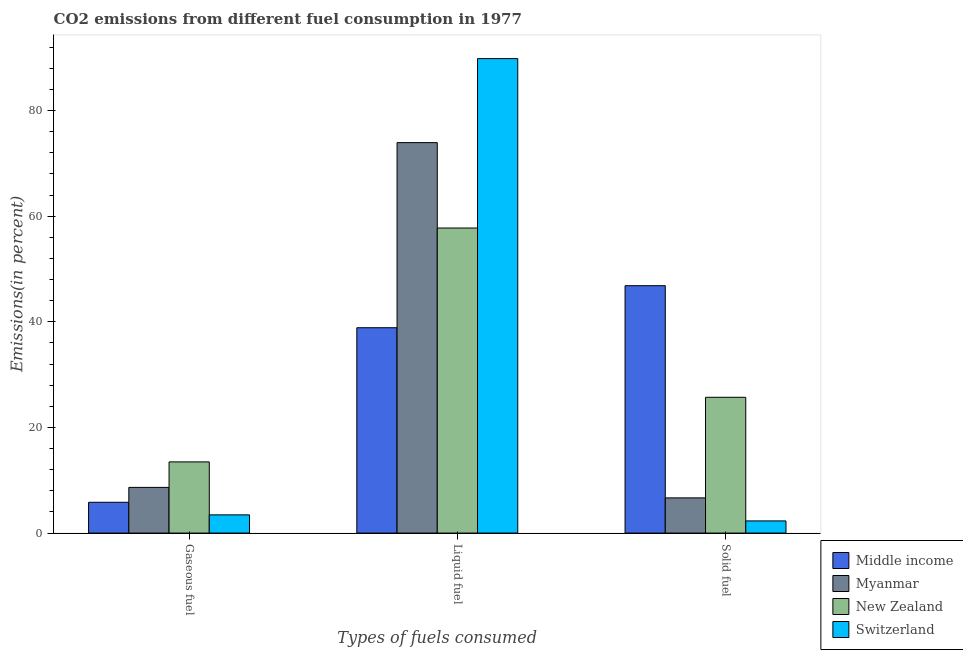Are the number of bars on each tick of the X-axis equal?
Give a very brief answer. Yes. How many bars are there on the 2nd tick from the left?
Your answer should be very brief. 4. How many bars are there on the 2nd tick from the right?
Ensure brevity in your answer.  4. What is the label of the 2nd group of bars from the left?
Give a very brief answer. Liquid fuel. What is the percentage of liquid fuel emission in New Zealand?
Your response must be concise. 57.75. Across all countries, what is the maximum percentage of solid fuel emission?
Keep it short and to the point. 46.83. Across all countries, what is the minimum percentage of solid fuel emission?
Offer a terse response. 2.3. In which country was the percentage of gaseous fuel emission maximum?
Provide a short and direct response. New Zealand. In which country was the percentage of gaseous fuel emission minimum?
Your answer should be very brief. Switzerland. What is the total percentage of solid fuel emission in the graph?
Provide a short and direct response. 81.5. What is the difference between the percentage of gaseous fuel emission in Myanmar and that in Switzerland?
Provide a succinct answer. 5.2. What is the difference between the percentage of liquid fuel emission in Switzerland and the percentage of solid fuel emission in Middle income?
Give a very brief answer. 42.99. What is the average percentage of gaseous fuel emission per country?
Your response must be concise. 7.85. What is the difference between the percentage of solid fuel emission and percentage of liquid fuel emission in New Zealand?
Your answer should be compact. -32.04. In how many countries, is the percentage of solid fuel emission greater than 60 %?
Provide a succinct answer. 0. What is the ratio of the percentage of gaseous fuel emission in New Zealand to that in Switzerland?
Your answer should be very brief. 3.91. Is the percentage of solid fuel emission in Myanmar less than that in Middle income?
Provide a short and direct response. Yes. What is the difference between the highest and the second highest percentage of gaseous fuel emission?
Offer a terse response. 4.83. What is the difference between the highest and the lowest percentage of solid fuel emission?
Provide a short and direct response. 44.53. In how many countries, is the percentage of liquid fuel emission greater than the average percentage of liquid fuel emission taken over all countries?
Your answer should be compact. 2. What does the 1st bar from the left in Solid fuel represents?
Provide a succinct answer. Middle income. What does the 1st bar from the right in Gaseous fuel represents?
Give a very brief answer. Switzerland. How many bars are there?
Provide a short and direct response. 12. Are all the bars in the graph horizontal?
Make the answer very short. No. How many countries are there in the graph?
Your answer should be compact. 4. What is the difference between two consecutive major ticks on the Y-axis?
Offer a very short reply. 20. Where does the legend appear in the graph?
Keep it short and to the point. Bottom right. What is the title of the graph?
Your response must be concise. CO2 emissions from different fuel consumption in 1977. Does "Sao Tome and Principe" appear as one of the legend labels in the graph?
Make the answer very short. No. What is the label or title of the X-axis?
Make the answer very short. Types of fuels consumed. What is the label or title of the Y-axis?
Your answer should be compact. Emissions(in percent). What is the Emissions(in percent) of Middle income in Gaseous fuel?
Ensure brevity in your answer.  5.83. What is the Emissions(in percent) in Myanmar in Gaseous fuel?
Provide a succinct answer. 8.65. What is the Emissions(in percent) in New Zealand in Gaseous fuel?
Provide a succinct answer. 13.48. What is the Emissions(in percent) of Switzerland in Gaseous fuel?
Your answer should be compact. 3.45. What is the Emissions(in percent) in Middle income in Liquid fuel?
Make the answer very short. 38.88. What is the Emissions(in percent) of Myanmar in Liquid fuel?
Your answer should be very brief. 73.92. What is the Emissions(in percent) in New Zealand in Liquid fuel?
Provide a short and direct response. 57.75. What is the Emissions(in percent) in Switzerland in Liquid fuel?
Give a very brief answer. 89.83. What is the Emissions(in percent) of Middle income in Solid fuel?
Provide a short and direct response. 46.83. What is the Emissions(in percent) in Myanmar in Solid fuel?
Give a very brief answer. 6.66. What is the Emissions(in percent) in New Zealand in Solid fuel?
Provide a succinct answer. 25.7. What is the Emissions(in percent) of Switzerland in Solid fuel?
Offer a terse response. 2.3. Across all Types of fuels consumed, what is the maximum Emissions(in percent) in Middle income?
Your answer should be compact. 46.83. Across all Types of fuels consumed, what is the maximum Emissions(in percent) in Myanmar?
Offer a very short reply. 73.92. Across all Types of fuels consumed, what is the maximum Emissions(in percent) in New Zealand?
Provide a succinct answer. 57.75. Across all Types of fuels consumed, what is the maximum Emissions(in percent) of Switzerland?
Your answer should be compact. 89.83. Across all Types of fuels consumed, what is the minimum Emissions(in percent) of Middle income?
Give a very brief answer. 5.83. Across all Types of fuels consumed, what is the minimum Emissions(in percent) in Myanmar?
Your response must be concise. 6.66. Across all Types of fuels consumed, what is the minimum Emissions(in percent) in New Zealand?
Your answer should be compact. 13.48. Across all Types of fuels consumed, what is the minimum Emissions(in percent) in Switzerland?
Keep it short and to the point. 2.3. What is the total Emissions(in percent) of Middle income in the graph?
Provide a succinct answer. 91.54. What is the total Emissions(in percent) in Myanmar in the graph?
Your answer should be very brief. 89.23. What is the total Emissions(in percent) of New Zealand in the graph?
Give a very brief answer. 96.93. What is the total Emissions(in percent) in Switzerland in the graph?
Your response must be concise. 95.57. What is the difference between the Emissions(in percent) of Middle income in Gaseous fuel and that in Liquid fuel?
Offer a very short reply. -33.05. What is the difference between the Emissions(in percent) of Myanmar in Gaseous fuel and that in Liquid fuel?
Your answer should be compact. -65.27. What is the difference between the Emissions(in percent) in New Zealand in Gaseous fuel and that in Liquid fuel?
Offer a terse response. -44.27. What is the difference between the Emissions(in percent) of Switzerland in Gaseous fuel and that in Liquid fuel?
Give a very brief answer. -86.38. What is the difference between the Emissions(in percent) of Middle income in Gaseous fuel and that in Solid fuel?
Offer a terse response. -41. What is the difference between the Emissions(in percent) in Myanmar in Gaseous fuel and that in Solid fuel?
Provide a short and direct response. 1.98. What is the difference between the Emissions(in percent) in New Zealand in Gaseous fuel and that in Solid fuel?
Make the answer very short. -12.23. What is the difference between the Emissions(in percent) in Switzerland in Gaseous fuel and that in Solid fuel?
Offer a terse response. 1.14. What is the difference between the Emissions(in percent) of Middle income in Liquid fuel and that in Solid fuel?
Offer a very short reply. -7.96. What is the difference between the Emissions(in percent) of Myanmar in Liquid fuel and that in Solid fuel?
Give a very brief answer. 67.26. What is the difference between the Emissions(in percent) of New Zealand in Liquid fuel and that in Solid fuel?
Make the answer very short. 32.04. What is the difference between the Emissions(in percent) in Switzerland in Liquid fuel and that in Solid fuel?
Your answer should be very brief. 87.52. What is the difference between the Emissions(in percent) of Middle income in Gaseous fuel and the Emissions(in percent) of Myanmar in Liquid fuel?
Your answer should be compact. -68.09. What is the difference between the Emissions(in percent) of Middle income in Gaseous fuel and the Emissions(in percent) of New Zealand in Liquid fuel?
Provide a short and direct response. -51.92. What is the difference between the Emissions(in percent) of Middle income in Gaseous fuel and the Emissions(in percent) of Switzerland in Liquid fuel?
Your answer should be compact. -84. What is the difference between the Emissions(in percent) in Myanmar in Gaseous fuel and the Emissions(in percent) in New Zealand in Liquid fuel?
Your answer should be very brief. -49.1. What is the difference between the Emissions(in percent) in Myanmar in Gaseous fuel and the Emissions(in percent) in Switzerland in Liquid fuel?
Your answer should be very brief. -81.18. What is the difference between the Emissions(in percent) of New Zealand in Gaseous fuel and the Emissions(in percent) of Switzerland in Liquid fuel?
Offer a terse response. -76.35. What is the difference between the Emissions(in percent) in Middle income in Gaseous fuel and the Emissions(in percent) in Myanmar in Solid fuel?
Provide a succinct answer. -0.83. What is the difference between the Emissions(in percent) in Middle income in Gaseous fuel and the Emissions(in percent) in New Zealand in Solid fuel?
Keep it short and to the point. -19.87. What is the difference between the Emissions(in percent) in Middle income in Gaseous fuel and the Emissions(in percent) in Switzerland in Solid fuel?
Your answer should be compact. 3.53. What is the difference between the Emissions(in percent) in Myanmar in Gaseous fuel and the Emissions(in percent) in New Zealand in Solid fuel?
Make the answer very short. -17.06. What is the difference between the Emissions(in percent) in Myanmar in Gaseous fuel and the Emissions(in percent) in Switzerland in Solid fuel?
Make the answer very short. 6.34. What is the difference between the Emissions(in percent) of New Zealand in Gaseous fuel and the Emissions(in percent) of Switzerland in Solid fuel?
Your answer should be compact. 11.17. What is the difference between the Emissions(in percent) of Middle income in Liquid fuel and the Emissions(in percent) of Myanmar in Solid fuel?
Keep it short and to the point. 32.21. What is the difference between the Emissions(in percent) in Middle income in Liquid fuel and the Emissions(in percent) in New Zealand in Solid fuel?
Provide a succinct answer. 13.17. What is the difference between the Emissions(in percent) in Middle income in Liquid fuel and the Emissions(in percent) in Switzerland in Solid fuel?
Keep it short and to the point. 36.57. What is the difference between the Emissions(in percent) of Myanmar in Liquid fuel and the Emissions(in percent) of New Zealand in Solid fuel?
Ensure brevity in your answer.  48.21. What is the difference between the Emissions(in percent) in Myanmar in Liquid fuel and the Emissions(in percent) in Switzerland in Solid fuel?
Give a very brief answer. 71.62. What is the difference between the Emissions(in percent) of New Zealand in Liquid fuel and the Emissions(in percent) of Switzerland in Solid fuel?
Provide a succinct answer. 55.45. What is the average Emissions(in percent) in Middle income per Types of fuels consumed?
Give a very brief answer. 30.51. What is the average Emissions(in percent) of Myanmar per Types of fuels consumed?
Offer a terse response. 29.74. What is the average Emissions(in percent) of New Zealand per Types of fuels consumed?
Provide a short and direct response. 32.31. What is the average Emissions(in percent) of Switzerland per Types of fuels consumed?
Make the answer very short. 31.86. What is the difference between the Emissions(in percent) of Middle income and Emissions(in percent) of Myanmar in Gaseous fuel?
Offer a terse response. -2.82. What is the difference between the Emissions(in percent) in Middle income and Emissions(in percent) in New Zealand in Gaseous fuel?
Your response must be concise. -7.65. What is the difference between the Emissions(in percent) of Middle income and Emissions(in percent) of Switzerland in Gaseous fuel?
Your answer should be very brief. 2.38. What is the difference between the Emissions(in percent) in Myanmar and Emissions(in percent) in New Zealand in Gaseous fuel?
Provide a succinct answer. -4.83. What is the difference between the Emissions(in percent) of Myanmar and Emissions(in percent) of Switzerland in Gaseous fuel?
Keep it short and to the point. 5.2. What is the difference between the Emissions(in percent) of New Zealand and Emissions(in percent) of Switzerland in Gaseous fuel?
Your answer should be very brief. 10.03. What is the difference between the Emissions(in percent) in Middle income and Emissions(in percent) in Myanmar in Liquid fuel?
Keep it short and to the point. -35.04. What is the difference between the Emissions(in percent) in Middle income and Emissions(in percent) in New Zealand in Liquid fuel?
Your answer should be compact. -18.87. What is the difference between the Emissions(in percent) of Middle income and Emissions(in percent) of Switzerland in Liquid fuel?
Provide a short and direct response. -50.95. What is the difference between the Emissions(in percent) of Myanmar and Emissions(in percent) of New Zealand in Liquid fuel?
Give a very brief answer. 16.17. What is the difference between the Emissions(in percent) of Myanmar and Emissions(in percent) of Switzerland in Liquid fuel?
Make the answer very short. -15.91. What is the difference between the Emissions(in percent) in New Zealand and Emissions(in percent) in Switzerland in Liquid fuel?
Provide a succinct answer. -32.08. What is the difference between the Emissions(in percent) of Middle income and Emissions(in percent) of Myanmar in Solid fuel?
Offer a terse response. 40.17. What is the difference between the Emissions(in percent) in Middle income and Emissions(in percent) in New Zealand in Solid fuel?
Make the answer very short. 21.13. What is the difference between the Emissions(in percent) in Middle income and Emissions(in percent) in Switzerland in Solid fuel?
Your answer should be compact. 44.53. What is the difference between the Emissions(in percent) of Myanmar and Emissions(in percent) of New Zealand in Solid fuel?
Your answer should be very brief. -19.04. What is the difference between the Emissions(in percent) in Myanmar and Emissions(in percent) in Switzerland in Solid fuel?
Offer a terse response. 4.36. What is the difference between the Emissions(in percent) in New Zealand and Emissions(in percent) in Switzerland in Solid fuel?
Provide a succinct answer. 23.4. What is the ratio of the Emissions(in percent) of Middle income in Gaseous fuel to that in Liquid fuel?
Ensure brevity in your answer.  0.15. What is the ratio of the Emissions(in percent) in Myanmar in Gaseous fuel to that in Liquid fuel?
Provide a succinct answer. 0.12. What is the ratio of the Emissions(in percent) in New Zealand in Gaseous fuel to that in Liquid fuel?
Make the answer very short. 0.23. What is the ratio of the Emissions(in percent) of Switzerland in Gaseous fuel to that in Liquid fuel?
Your answer should be very brief. 0.04. What is the ratio of the Emissions(in percent) in Middle income in Gaseous fuel to that in Solid fuel?
Ensure brevity in your answer.  0.12. What is the ratio of the Emissions(in percent) in Myanmar in Gaseous fuel to that in Solid fuel?
Give a very brief answer. 1.3. What is the ratio of the Emissions(in percent) of New Zealand in Gaseous fuel to that in Solid fuel?
Your answer should be compact. 0.52. What is the ratio of the Emissions(in percent) in Switzerland in Gaseous fuel to that in Solid fuel?
Your response must be concise. 1.5. What is the ratio of the Emissions(in percent) of Middle income in Liquid fuel to that in Solid fuel?
Offer a terse response. 0.83. What is the ratio of the Emissions(in percent) in Myanmar in Liquid fuel to that in Solid fuel?
Your answer should be very brief. 11.1. What is the ratio of the Emissions(in percent) of New Zealand in Liquid fuel to that in Solid fuel?
Give a very brief answer. 2.25. What is the ratio of the Emissions(in percent) in Switzerland in Liquid fuel to that in Solid fuel?
Ensure brevity in your answer.  39.01. What is the difference between the highest and the second highest Emissions(in percent) in Middle income?
Provide a short and direct response. 7.96. What is the difference between the highest and the second highest Emissions(in percent) of Myanmar?
Your answer should be compact. 65.27. What is the difference between the highest and the second highest Emissions(in percent) of New Zealand?
Offer a very short reply. 32.04. What is the difference between the highest and the second highest Emissions(in percent) in Switzerland?
Offer a very short reply. 86.38. What is the difference between the highest and the lowest Emissions(in percent) of Middle income?
Give a very brief answer. 41. What is the difference between the highest and the lowest Emissions(in percent) in Myanmar?
Your answer should be very brief. 67.26. What is the difference between the highest and the lowest Emissions(in percent) in New Zealand?
Provide a short and direct response. 44.27. What is the difference between the highest and the lowest Emissions(in percent) of Switzerland?
Provide a short and direct response. 87.52. 